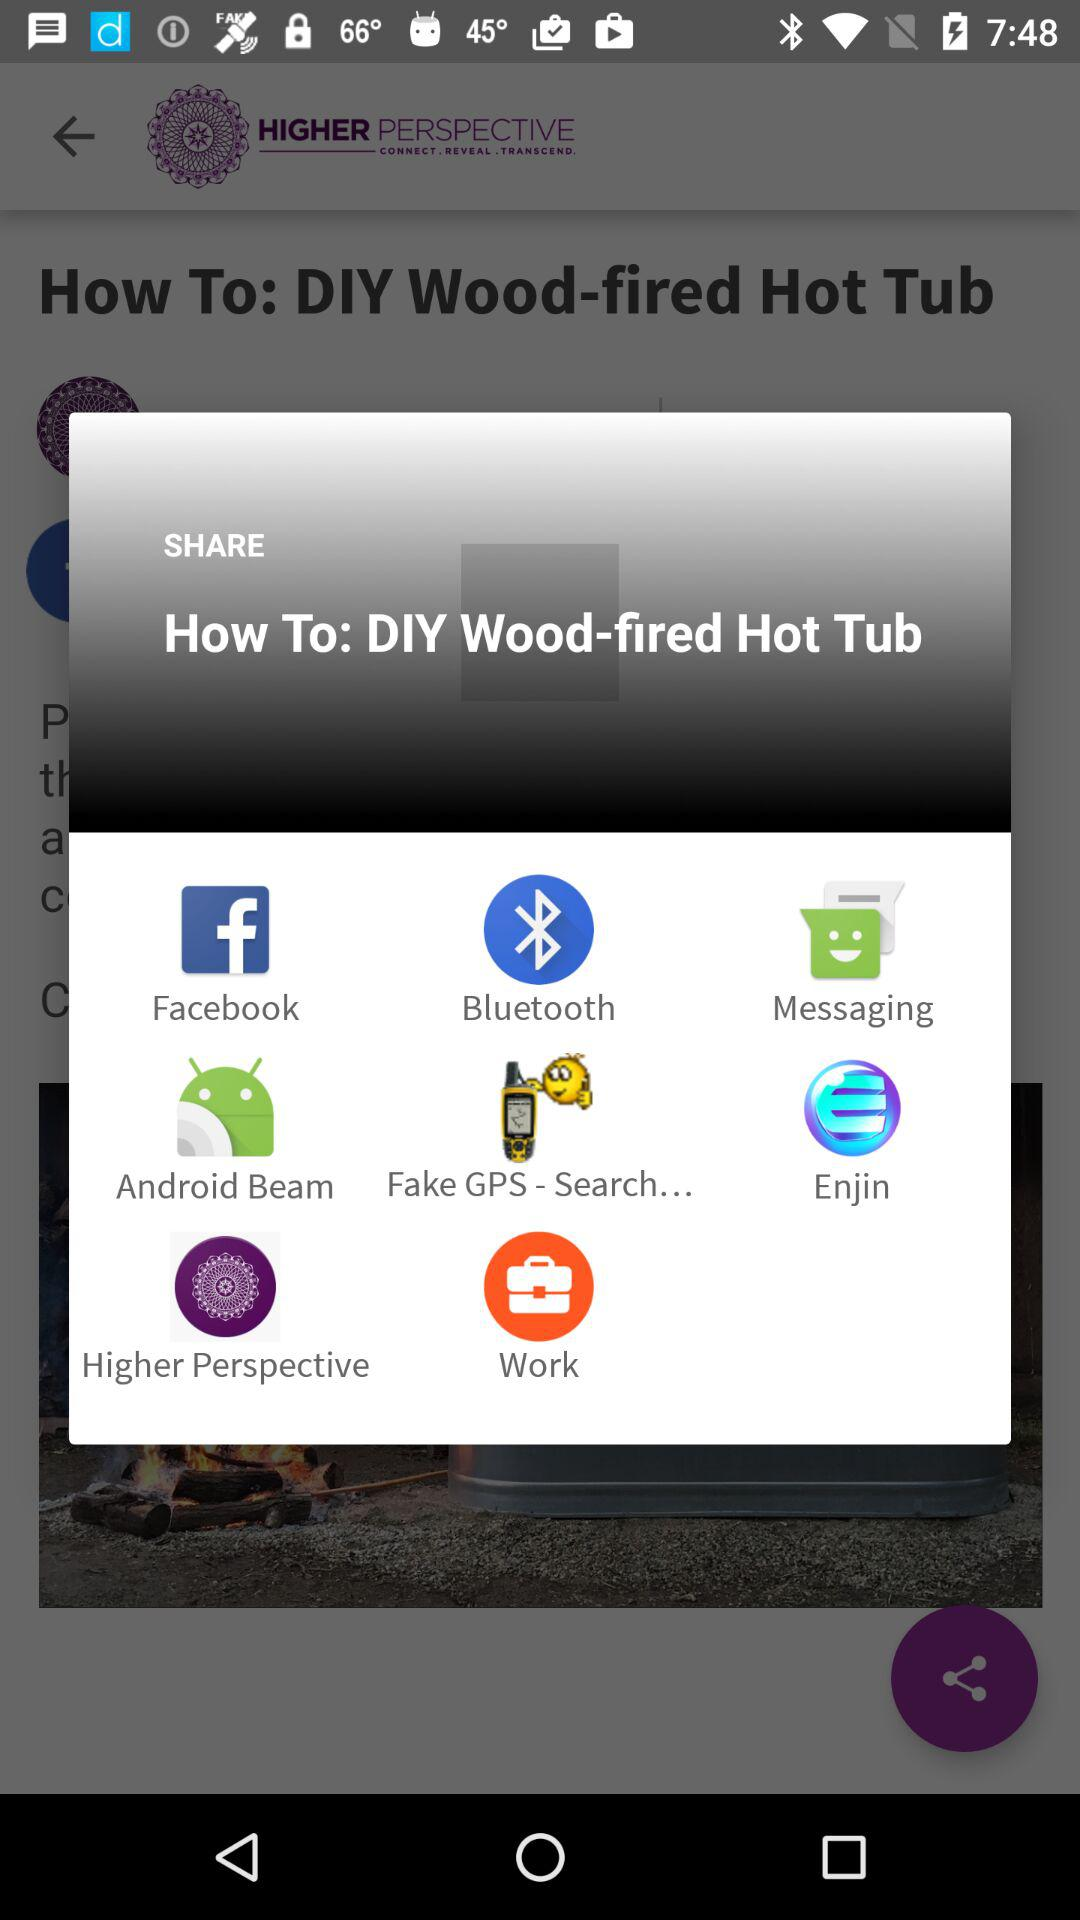What are the available sharing options? The available sharing options are "Facebook", "Bluetooth", "Messaging", "Android Beam", "Fake GPS - Search...", "Enjin", "Higher Perspective" and "Work". 